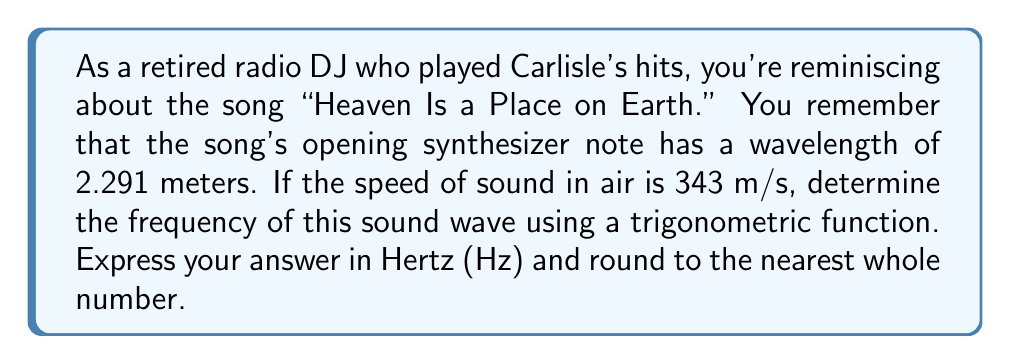Solve this math problem. To solve this problem, we'll use the relationship between wavelength, frequency, and speed of sound. The general equation for a wave is:

$$ v = f\lambda $$

Where:
$v$ = speed of sound (343 m/s)
$f$ = frequency (Hz)
$\lambda$ = wavelength (2.291 m)

We need to solve for $f$. Rearranging the equation:

$$ f = \frac{v}{\lambda} $$

Now, let's substitute the known values:

$$ f = \frac{343 \text{ m/s}}{2.291 \text{ m}} $$

Using a calculator:

$$ f \approx 149.7162 \text{ Hz} $$

Rounding to the nearest whole number:

$$ f \approx 150 \text{ Hz} $$

This frequency can be represented using a sine function:

$$ y(t) = A \sin(2\pi ft) $$

Where $A$ is the amplitude and $t$ is time. For this specific frequency:

$$ y(t) = A \sin(2\pi \cdot 150 \cdot t) $$

This trigonometric function represents the sound wave of the opening synthesizer note in "Heaven Is a Place on Earth."
Answer: 150 Hz 